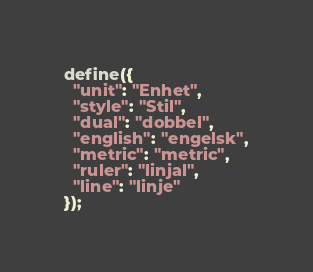<code> <loc_0><loc_0><loc_500><loc_500><_JavaScript_>define({
  "unit": "Enhet",
  "style": "Stil",
  "dual": "dobbel",
  "english": "engelsk",
  "metric": "metric",
  "ruler": "linjal",
  "line": "linje"
});</code> 